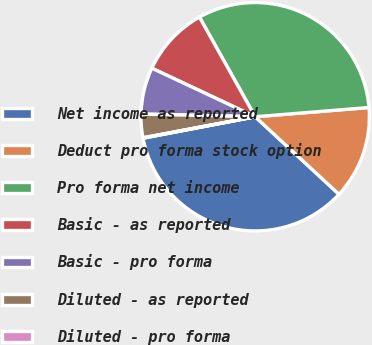<chart> <loc_0><loc_0><loc_500><loc_500><pie_chart><fcel>Net income as reported<fcel>Deduct pro forma stock option<fcel>Pro forma net income<fcel>Basic - as reported<fcel>Basic - pro forma<fcel>Diluted - as reported<fcel>Diluted - pro forma<nl><fcel>35.11%<fcel>13.17%<fcel>31.83%<fcel>9.89%<fcel>6.61%<fcel>3.33%<fcel>0.06%<nl></chart> 